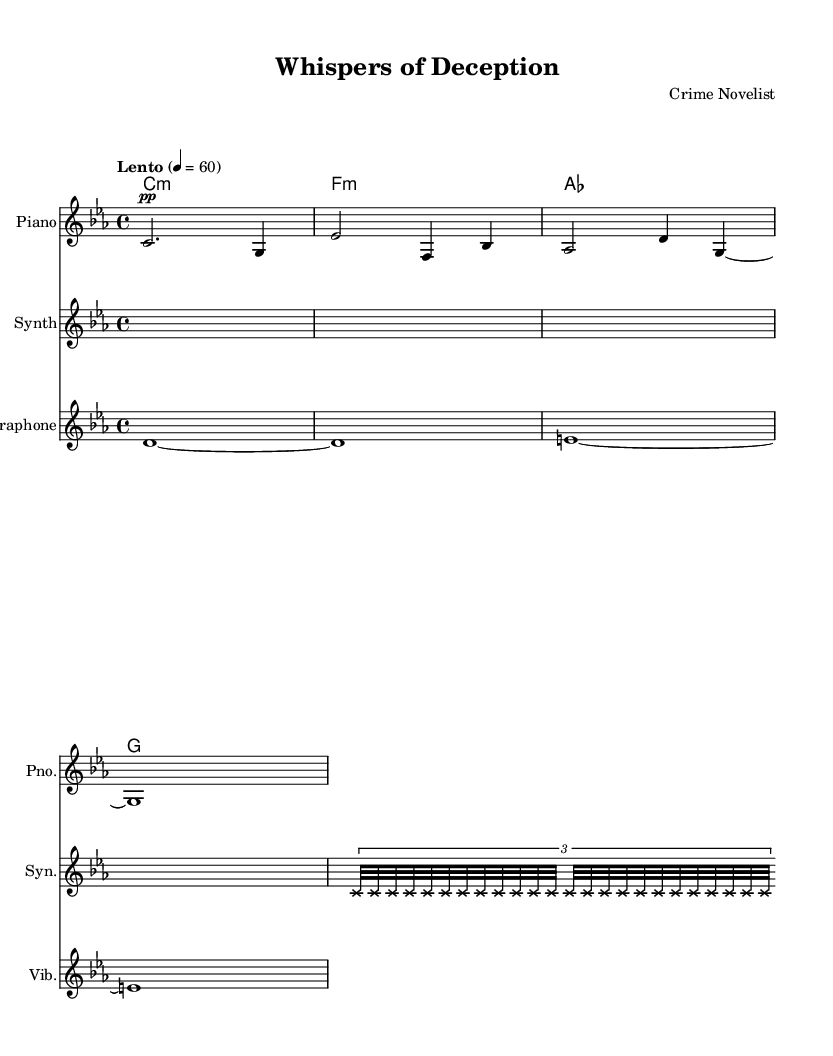What is the key signature of this music? The key signature is C minor, indicated by three flats (B flat, E flat, and A flat) written at the beginning of the staff.
Answer: C minor What is the time signature of this piece? The time signature is found at the beginning of the piece, showing four beats per measure, indicated by the fraction 4/4.
Answer: 4/4 What is the tempo marking given in the score? The tempo marking tells the musician the pace at which to play. It is marked as "Lento," which indicates a slow tempo, and the metronome marking of quarter note equals 60 provides the exact speed.
Answer: Lento How many different instruments are present in this score? By examining the score, three different instruments are listed, each having its own staff: Piano, Synthesizer, and Vibraphone.
Answer: Three What type of musical structure is predominantly featured in the synthesizer part? The synthesizer part demonstrates a repetitive structure through the use of a tuplet that unfolds 24 notes, creating a continuous sound. This pattern emphasizes the ambient style.
Answer: Repetitive structure Which chord type is first notated in the chord names? The chord names indicate the first chord listed is C minor, represented as 'c1:m,' confirming the tonality of the piece.
Answer: C minor How long does the vibraphone sustain the first note? The first note of the vibraphone is notated with a whole note, which indicates it is sustained for the full measure (four beats).
Answer: Whole note 